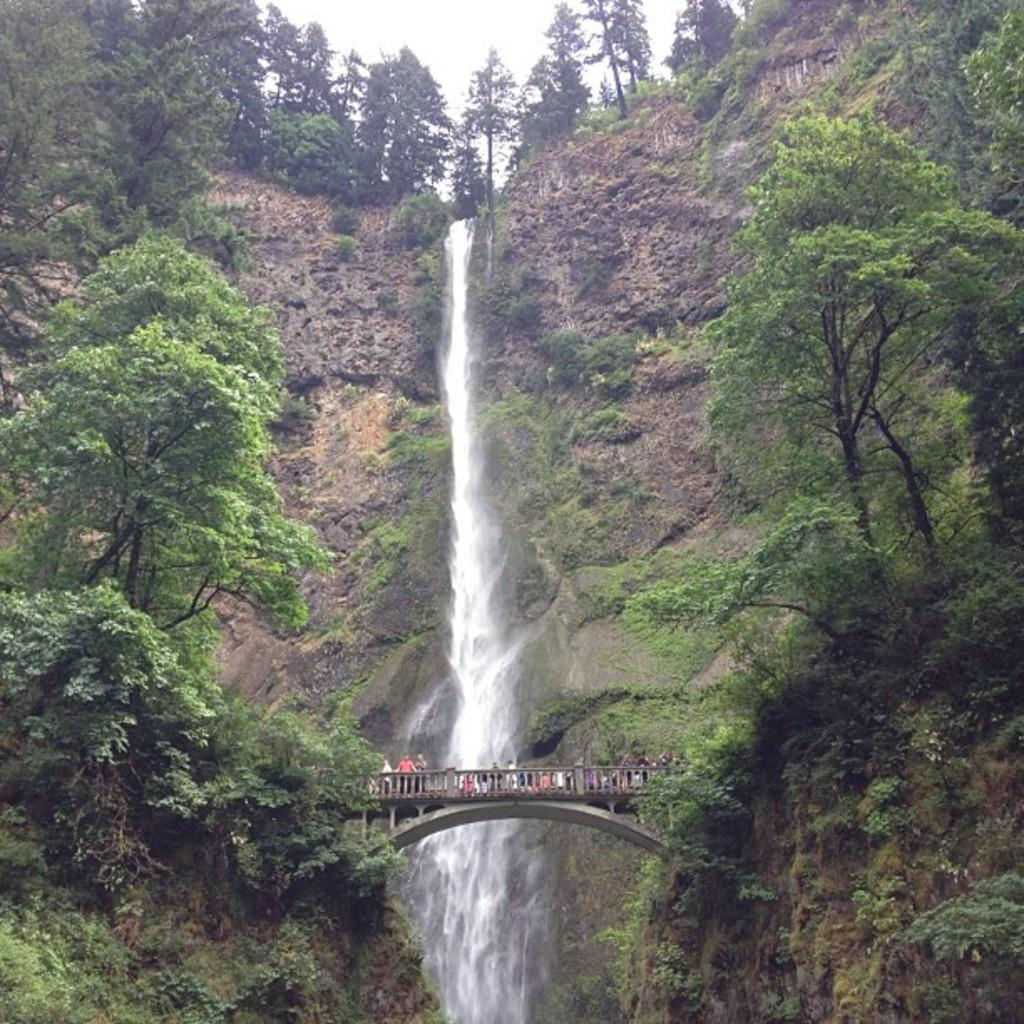What is the main structure in the middle of the image? There is a bridge in the middle of the image. What is happening on the bridge? There are people on the bridge. What can be seen in the background of the image? There is a waterfall in the background of the image. What type of vegetation is present near the bridge? Trees are present on either side of the bridge. What type of force is being applied to the sand in the image? There is no sand present in the image, so no force can be applied to it. 